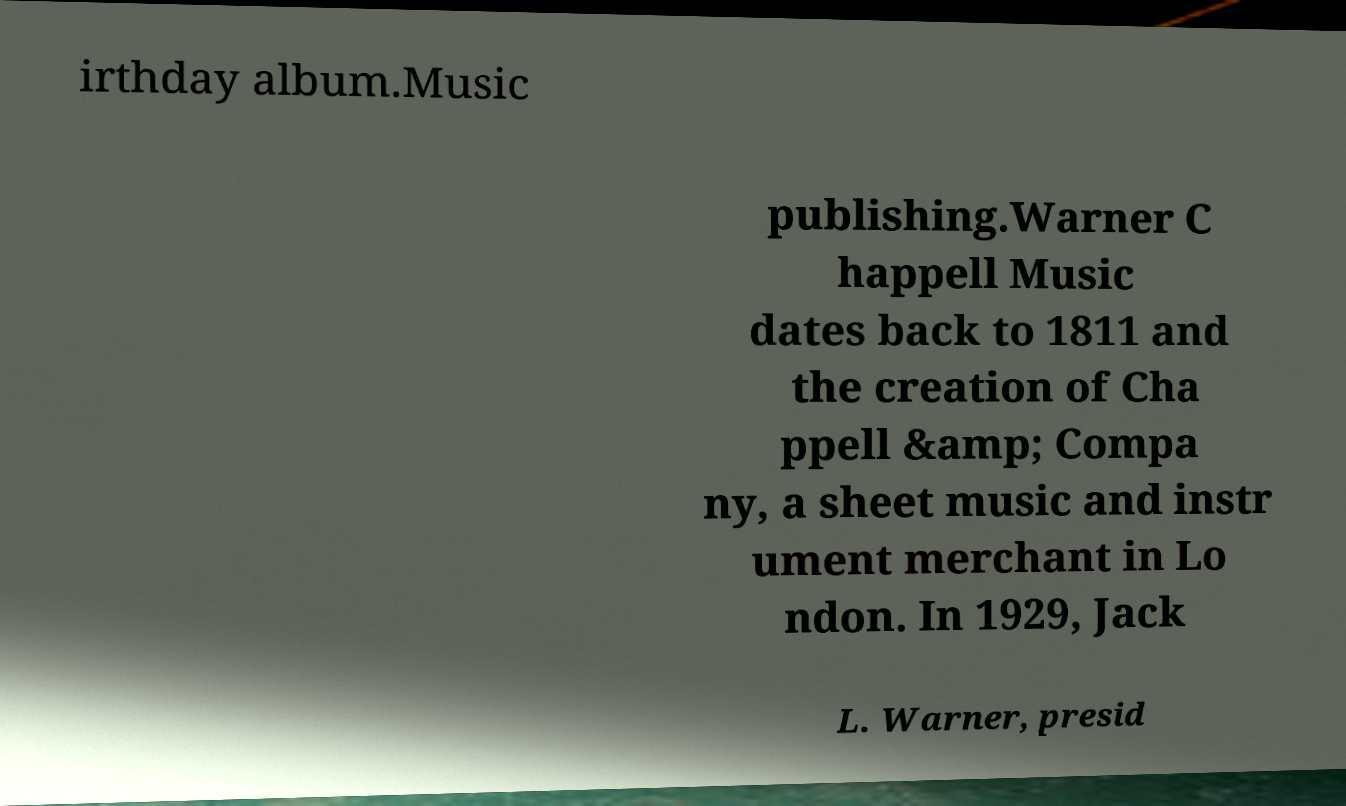Please identify and transcribe the text found in this image. irthday album.Music publishing.Warner C happell Music dates back to 1811 and the creation of Cha ppell &amp; Compa ny, a sheet music and instr ument merchant in Lo ndon. In 1929, Jack L. Warner, presid 